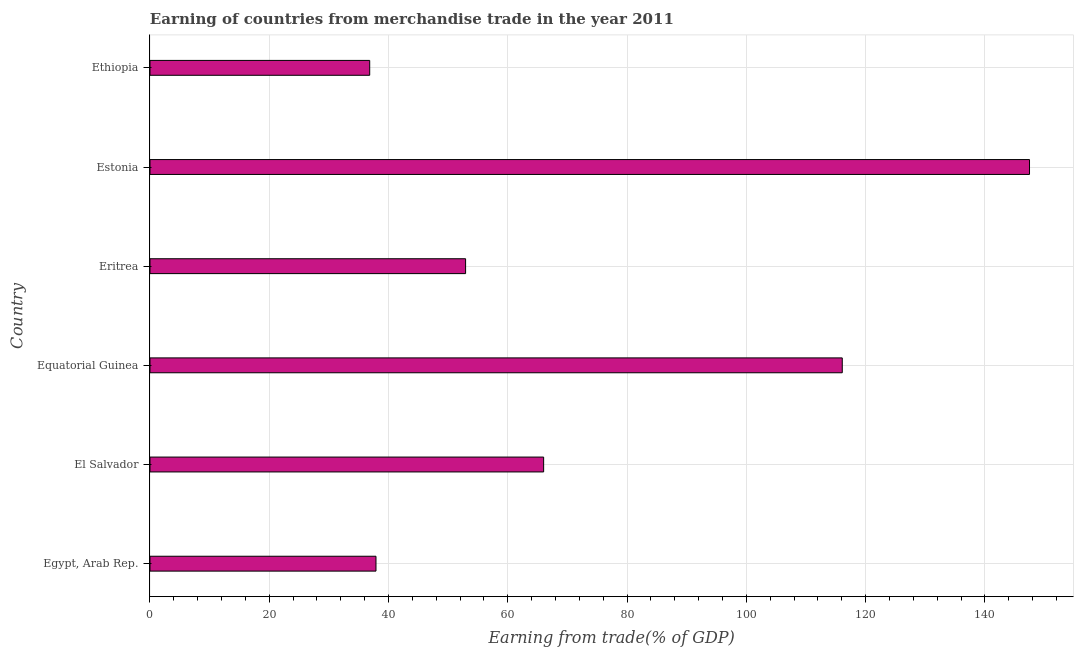What is the title of the graph?
Make the answer very short. Earning of countries from merchandise trade in the year 2011. What is the label or title of the X-axis?
Give a very brief answer. Earning from trade(% of GDP). What is the earning from merchandise trade in Ethiopia?
Keep it short and to the point. 36.84. Across all countries, what is the maximum earning from merchandise trade?
Offer a terse response. 147.47. Across all countries, what is the minimum earning from merchandise trade?
Provide a short and direct response. 36.84. In which country was the earning from merchandise trade maximum?
Give a very brief answer. Estonia. In which country was the earning from merchandise trade minimum?
Offer a terse response. Ethiopia. What is the sum of the earning from merchandise trade?
Provide a succinct answer. 457.21. What is the difference between the earning from merchandise trade in Equatorial Guinea and Estonia?
Your answer should be very brief. -31.4. What is the average earning from merchandise trade per country?
Offer a very short reply. 76.2. What is the median earning from merchandise trade?
Offer a terse response. 59.46. In how many countries, is the earning from merchandise trade greater than 104 %?
Your answer should be very brief. 2. What is the ratio of the earning from merchandise trade in Egypt, Arab Rep. to that in Eritrea?
Your response must be concise. 0.72. Is the earning from merchandise trade in Egypt, Arab Rep. less than that in Equatorial Guinea?
Your response must be concise. Yes. What is the difference between the highest and the second highest earning from merchandise trade?
Give a very brief answer. 31.4. Is the sum of the earning from merchandise trade in El Salvador and Equatorial Guinea greater than the maximum earning from merchandise trade across all countries?
Provide a short and direct response. Yes. What is the difference between the highest and the lowest earning from merchandise trade?
Provide a short and direct response. 110.63. In how many countries, is the earning from merchandise trade greater than the average earning from merchandise trade taken over all countries?
Offer a terse response. 2. Are the values on the major ticks of X-axis written in scientific E-notation?
Give a very brief answer. No. What is the Earning from trade(% of GDP) in Egypt, Arab Rep.?
Give a very brief answer. 37.89. What is the Earning from trade(% of GDP) of El Salvador?
Make the answer very short. 66. What is the Earning from trade(% of GDP) in Equatorial Guinea?
Your answer should be compact. 116.08. What is the Earning from trade(% of GDP) of Eritrea?
Your response must be concise. 52.92. What is the Earning from trade(% of GDP) of Estonia?
Offer a very short reply. 147.47. What is the Earning from trade(% of GDP) of Ethiopia?
Provide a short and direct response. 36.84. What is the difference between the Earning from trade(% of GDP) in Egypt, Arab Rep. and El Salvador?
Your answer should be compact. -28.11. What is the difference between the Earning from trade(% of GDP) in Egypt, Arab Rep. and Equatorial Guinea?
Provide a short and direct response. -78.18. What is the difference between the Earning from trade(% of GDP) in Egypt, Arab Rep. and Eritrea?
Provide a short and direct response. -15.03. What is the difference between the Earning from trade(% of GDP) in Egypt, Arab Rep. and Estonia?
Offer a very short reply. -109.58. What is the difference between the Earning from trade(% of GDP) in Egypt, Arab Rep. and Ethiopia?
Keep it short and to the point. 1.05. What is the difference between the Earning from trade(% of GDP) in El Salvador and Equatorial Guinea?
Provide a short and direct response. -50.07. What is the difference between the Earning from trade(% of GDP) in El Salvador and Eritrea?
Keep it short and to the point. 13.09. What is the difference between the Earning from trade(% of GDP) in El Salvador and Estonia?
Your response must be concise. -81.47. What is the difference between the Earning from trade(% of GDP) in El Salvador and Ethiopia?
Keep it short and to the point. 29.16. What is the difference between the Earning from trade(% of GDP) in Equatorial Guinea and Eritrea?
Keep it short and to the point. 63.16. What is the difference between the Earning from trade(% of GDP) in Equatorial Guinea and Estonia?
Provide a short and direct response. -31.4. What is the difference between the Earning from trade(% of GDP) in Equatorial Guinea and Ethiopia?
Provide a short and direct response. 79.24. What is the difference between the Earning from trade(% of GDP) in Eritrea and Estonia?
Make the answer very short. -94.56. What is the difference between the Earning from trade(% of GDP) in Eritrea and Ethiopia?
Offer a very short reply. 16.08. What is the difference between the Earning from trade(% of GDP) in Estonia and Ethiopia?
Provide a succinct answer. 110.63. What is the ratio of the Earning from trade(% of GDP) in Egypt, Arab Rep. to that in El Salvador?
Give a very brief answer. 0.57. What is the ratio of the Earning from trade(% of GDP) in Egypt, Arab Rep. to that in Equatorial Guinea?
Make the answer very short. 0.33. What is the ratio of the Earning from trade(% of GDP) in Egypt, Arab Rep. to that in Eritrea?
Provide a succinct answer. 0.72. What is the ratio of the Earning from trade(% of GDP) in Egypt, Arab Rep. to that in Estonia?
Keep it short and to the point. 0.26. What is the ratio of the Earning from trade(% of GDP) in El Salvador to that in Equatorial Guinea?
Give a very brief answer. 0.57. What is the ratio of the Earning from trade(% of GDP) in El Salvador to that in Eritrea?
Provide a succinct answer. 1.25. What is the ratio of the Earning from trade(% of GDP) in El Salvador to that in Estonia?
Keep it short and to the point. 0.45. What is the ratio of the Earning from trade(% of GDP) in El Salvador to that in Ethiopia?
Offer a terse response. 1.79. What is the ratio of the Earning from trade(% of GDP) in Equatorial Guinea to that in Eritrea?
Provide a short and direct response. 2.19. What is the ratio of the Earning from trade(% of GDP) in Equatorial Guinea to that in Estonia?
Offer a terse response. 0.79. What is the ratio of the Earning from trade(% of GDP) in Equatorial Guinea to that in Ethiopia?
Give a very brief answer. 3.15. What is the ratio of the Earning from trade(% of GDP) in Eritrea to that in Estonia?
Make the answer very short. 0.36. What is the ratio of the Earning from trade(% of GDP) in Eritrea to that in Ethiopia?
Ensure brevity in your answer.  1.44. What is the ratio of the Earning from trade(% of GDP) in Estonia to that in Ethiopia?
Ensure brevity in your answer.  4. 